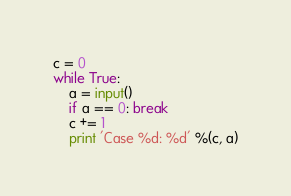Convert code to text. <code><loc_0><loc_0><loc_500><loc_500><_Python_>c = 0
while True:
    a = input()
    if a == 0: break
    c += 1
    print 'Case %d: %d' %(c, a)</code> 